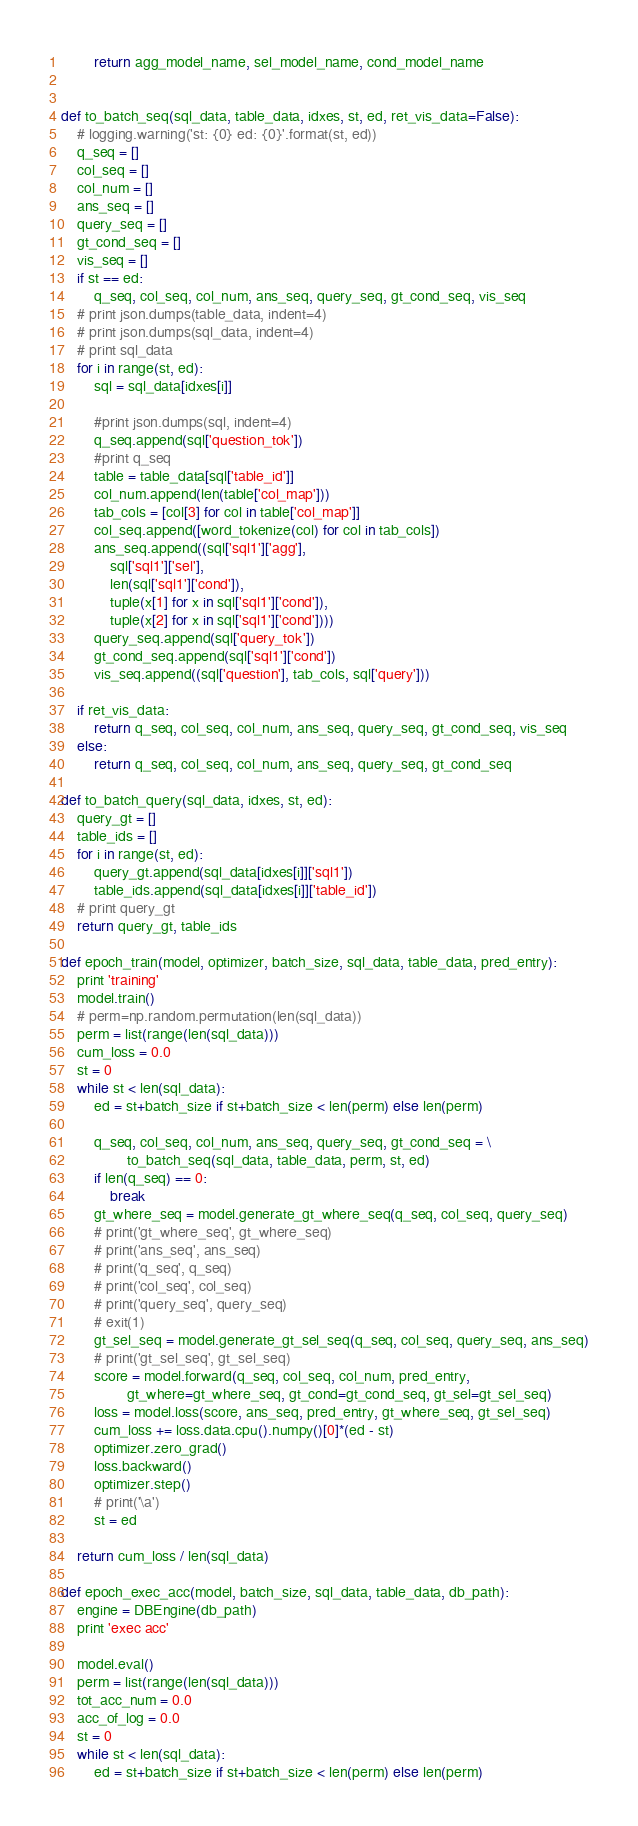<code> <loc_0><loc_0><loc_500><loc_500><_Python_>        return agg_model_name, sel_model_name, cond_model_name


def to_batch_seq(sql_data, table_data, idxes, st, ed, ret_vis_data=False):
    # logging.warning('st: {0} ed: {0}'.format(st, ed))
    q_seq = []
    col_seq = []
    col_num = []
    ans_seq = []
    query_seq = []
    gt_cond_seq = []
    vis_seq = []
    if st == ed:
        q_seq, col_seq, col_num, ans_seq, query_seq, gt_cond_seq, vis_seq
    # print json.dumps(table_data, indent=4)
    # print json.dumps(sql_data, indent=4)
    # print sql_data
    for i in range(st, ed):
        sql = sql_data[idxes[i]]

        #print json.dumps(sql, indent=4)
        q_seq.append(sql['question_tok']) 
        #print q_seq
        table = table_data[sql['table_id']]
        col_num.append(len(table['col_map']))
        tab_cols = [col[3] for col in table['col_map']]
        col_seq.append([word_tokenize(col) for col in tab_cols]) 
        ans_seq.append((sql['sql1']['agg'], 
            sql['sql1']['sel'], 
            len(sql['sql1']['cond']), 
            tuple(x[1] for x in sql['sql1']['cond']), 
            tuple(x[2] for x in sql['sql1']['cond']))) 
        query_seq.append(sql['query_tok'])
        gt_cond_seq.append(sql['sql1']['cond'])
        vis_seq.append((sql['question'], tab_cols, sql['query']))

    if ret_vis_data:
        return q_seq, col_seq, col_num, ans_seq, query_seq, gt_cond_seq, vis_seq
    else:
        return q_seq, col_seq, col_num, ans_seq, query_seq, gt_cond_seq

def to_batch_query(sql_data, idxes, st, ed):
    query_gt = []
    table_ids = []
    for i in range(st, ed):
        query_gt.append(sql_data[idxes[i]]['sql1'])
        table_ids.append(sql_data[idxes[i]]['table_id'])
    # print query_gt
    return query_gt, table_ids

def epoch_train(model, optimizer, batch_size, sql_data, table_data, pred_entry):
    print 'training'
    model.train()
    # perm=np.random.permutation(len(sql_data))
    perm = list(range(len(sql_data)))
    cum_loss = 0.0
    st = 0
    while st < len(sql_data):
        ed = st+batch_size if st+batch_size < len(perm) else len(perm)

        q_seq, col_seq, col_num, ans_seq, query_seq, gt_cond_seq = \
                to_batch_seq(sql_data, table_data, perm, st, ed)
        if len(q_seq) == 0:
            break
        gt_where_seq = model.generate_gt_where_seq(q_seq, col_seq, query_seq)
        # print('gt_where_seq', gt_where_seq)
        # print('ans_seq', ans_seq)
        # print('q_seq', q_seq)
        # print('col_seq', col_seq)
        # print('query_seq', query_seq)
        # exit(1)
        gt_sel_seq = model.generate_gt_sel_seq(q_seq, col_seq, query_seq, ans_seq)
        # print('gt_sel_seq', gt_sel_seq)
        score = model.forward(q_seq, col_seq, col_num, pred_entry,
                gt_where=gt_where_seq, gt_cond=gt_cond_seq, gt_sel=gt_sel_seq)
        loss = model.loss(score, ans_seq, pred_entry, gt_where_seq, gt_sel_seq)
        cum_loss += loss.data.cpu().numpy()[0]*(ed - st)
        optimizer.zero_grad()
        loss.backward()
        optimizer.step()
        # print('\a')
        st = ed

    return cum_loss / len(sql_data)

def epoch_exec_acc(model, batch_size, sql_data, table_data, db_path):
    engine = DBEngine(db_path)
    print 'exec acc'

    model.eval()
    perm = list(range(len(sql_data)))
    tot_acc_num = 0.0
    acc_of_log = 0.0
    st = 0
    while st < len(sql_data):
        ed = st+batch_size if st+batch_size < len(perm) else len(perm)</code> 